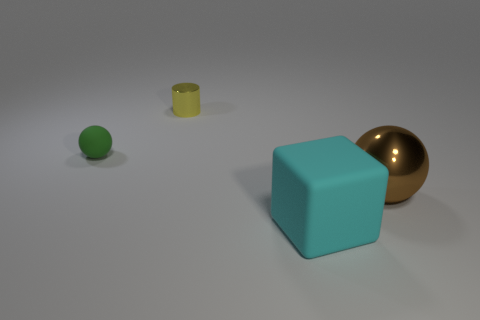Add 1 large gray cylinders. How many objects exist? 5 Subtract all cubes. How many objects are left? 3 Subtract 0 purple spheres. How many objects are left? 4 Subtract all brown metallic objects. Subtract all brown metallic spheres. How many objects are left? 2 Add 3 green objects. How many green objects are left? 4 Add 1 blocks. How many blocks exist? 2 